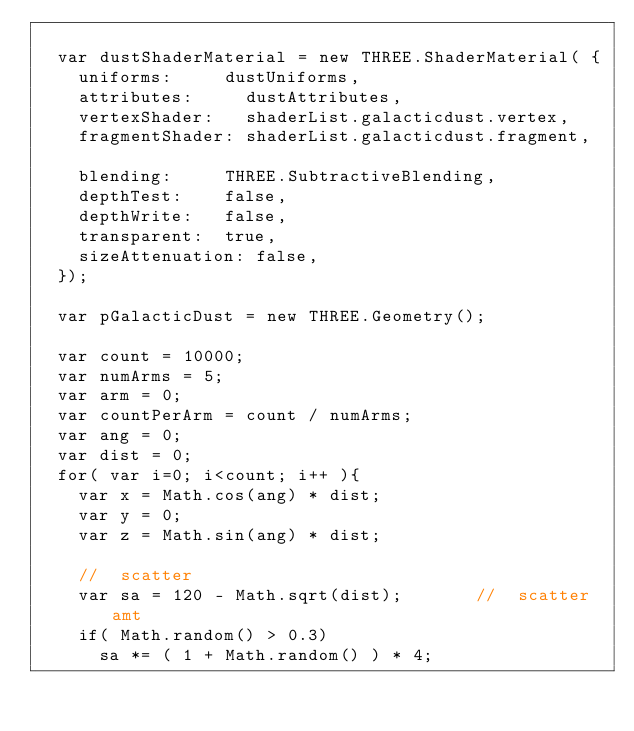<code> <loc_0><loc_0><loc_500><loc_500><_JavaScript_>
	var dustShaderMaterial = new THREE.ShaderMaterial( {
		uniforms: 		dustUniforms,
		attributes:     dustAttributes,
		vertexShader:   shaderList.galacticdust.vertex,
		fragmentShader: shaderList.galacticdust.fragment,

		blending: 		THREE.SubtractiveBlending,
		depthTest: 		false,
		depthWrite: 	false,
		transparent:	true,
		sizeAttenuation: false,		
	});	

	var pGalacticDust = new THREE.Geometry();	

	var count = 10000;
	var numArms = 5;
	var arm = 0;
	var countPerArm = count / numArms;
	var ang = 0;
	var dist = 0;
	for( var i=0; i<count; i++ ){
		var x = Math.cos(ang) * dist;
		var y = 0;
		var z = Math.sin(ang) * dist;

		//	scatter
		var sa = 120 - Math.sqrt(dist);				//	scatter amt
		if( Math.random() > 0.3)
			sa *= ( 1 + Math.random() ) * 4;</code> 